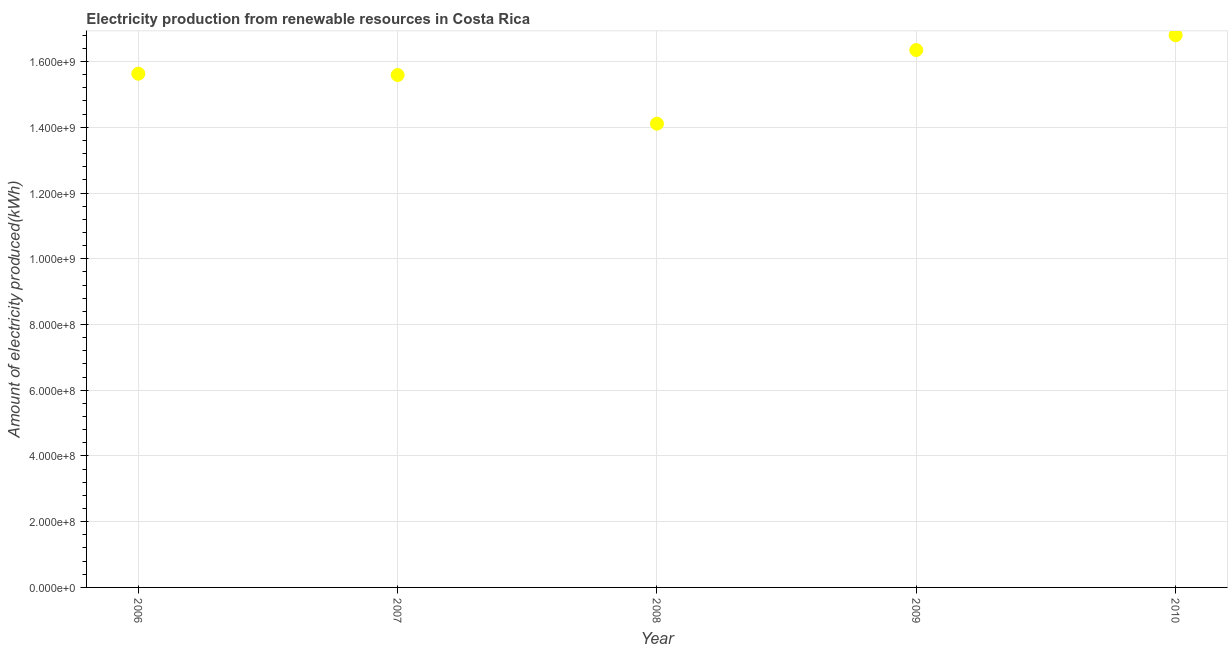What is the amount of electricity produced in 2010?
Your answer should be compact. 1.68e+09. Across all years, what is the maximum amount of electricity produced?
Make the answer very short. 1.68e+09. Across all years, what is the minimum amount of electricity produced?
Your response must be concise. 1.41e+09. In which year was the amount of electricity produced maximum?
Ensure brevity in your answer.  2010. What is the sum of the amount of electricity produced?
Give a very brief answer. 7.85e+09. What is the difference between the amount of electricity produced in 2008 and 2009?
Offer a very short reply. -2.24e+08. What is the average amount of electricity produced per year?
Offer a very short reply. 1.57e+09. What is the median amount of electricity produced?
Ensure brevity in your answer.  1.56e+09. In how many years, is the amount of electricity produced greater than 1560000000 kWh?
Provide a short and direct response. 3. Do a majority of the years between 2010 and 2008 (inclusive) have amount of electricity produced greater than 1200000000 kWh?
Provide a short and direct response. No. What is the ratio of the amount of electricity produced in 2006 to that in 2010?
Offer a terse response. 0.93. Is the difference between the amount of electricity produced in 2006 and 2008 greater than the difference between any two years?
Give a very brief answer. No. What is the difference between the highest and the second highest amount of electricity produced?
Your answer should be very brief. 4.50e+07. Is the sum of the amount of electricity produced in 2008 and 2010 greater than the maximum amount of electricity produced across all years?
Provide a short and direct response. Yes. What is the difference between the highest and the lowest amount of electricity produced?
Offer a terse response. 2.69e+08. What is the difference between two consecutive major ticks on the Y-axis?
Your answer should be compact. 2.00e+08. Does the graph contain grids?
Keep it short and to the point. Yes. What is the title of the graph?
Your response must be concise. Electricity production from renewable resources in Costa Rica. What is the label or title of the Y-axis?
Give a very brief answer. Amount of electricity produced(kWh). What is the Amount of electricity produced(kWh) in 2006?
Give a very brief answer. 1.56e+09. What is the Amount of electricity produced(kWh) in 2007?
Keep it short and to the point. 1.56e+09. What is the Amount of electricity produced(kWh) in 2008?
Keep it short and to the point. 1.41e+09. What is the Amount of electricity produced(kWh) in 2009?
Give a very brief answer. 1.64e+09. What is the Amount of electricity produced(kWh) in 2010?
Offer a very short reply. 1.68e+09. What is the difference between the Amount of electricity produced(kWh) in 2006 and 2008?
Make the answer very short. 1.52e+08. What is the difference between the Amount of electricity produced(kWh) in 2006 and 2009?
Keep it short and to the point. -7.20e+07. What is the difference between the Amount of electricity produced(kWh) in 2006 and 2010?
Keep it short and to the point. -1.17e+08. What is the difference between the Amount of electricity produced(kWh) in 2007 and 2008?
Offer a very short reply. 1.48e+08. What is the difference between the Amount of electricity produced(kWh) in 2007 and 2009?
Your response must be concise. -7.60e+07. What is the difference between the Amount of electricity produced(kWh) in 2007 and 2010?
Ensure brevity in your answer.  -1.21e+08. What is the difference between the Amount of electricity produced(kWh) in 2008 and 2009?
Provide a succinct answer. -2.24e+08. What is the difference between the Amount of electricity produced(kWh) in 2008 and 2010?
Give a very brief answer. -2.69e+08. What is the difference between the Amount of electricity produced(kWh) in 2009 and 2010?
Keep it short and to the point. -4.50e+07. What is the ratio of the Amount of electricity produced(kWh) in 2006 to that in 2007?
Give a very brief answer. 1. What is the ratio of the Amount of electricity produced(kWh) in 2006 to that in 2008?
Give a very brief answer. 1.11. What is the ratio of the Amount of electricity produced(kWh) in 2006 to that in 2009?
Provide a succinct answer. 0.96. What is the ratio of the Amount of electricity produced(kWh) in 2007 to that in 2008?
Offer a terse response. 1.1. What is the ratio of the Amount of electricity produced(kWh) in 2007 to that in 2009?
Your answer should be compact. 0.95. What is the ratio of the Amount of electricity produced(kWh) in 2007 to that in 2010?
Provide a succinct answer. 0.93. What is the ratio of the Amount of electricity produced(kWh) in 2008 to that in 2009?
Provide a succinct answer. 0.86. What is the ratio of the Amount of electricity produced(kWh) in 2008 to that in 2010?
Provide a succinct answer. 0.84. What is the ratio of the Amount of electricity produced(kWh) in 2009 to that in 2010?
Your answer should be very brief. 0.97. 